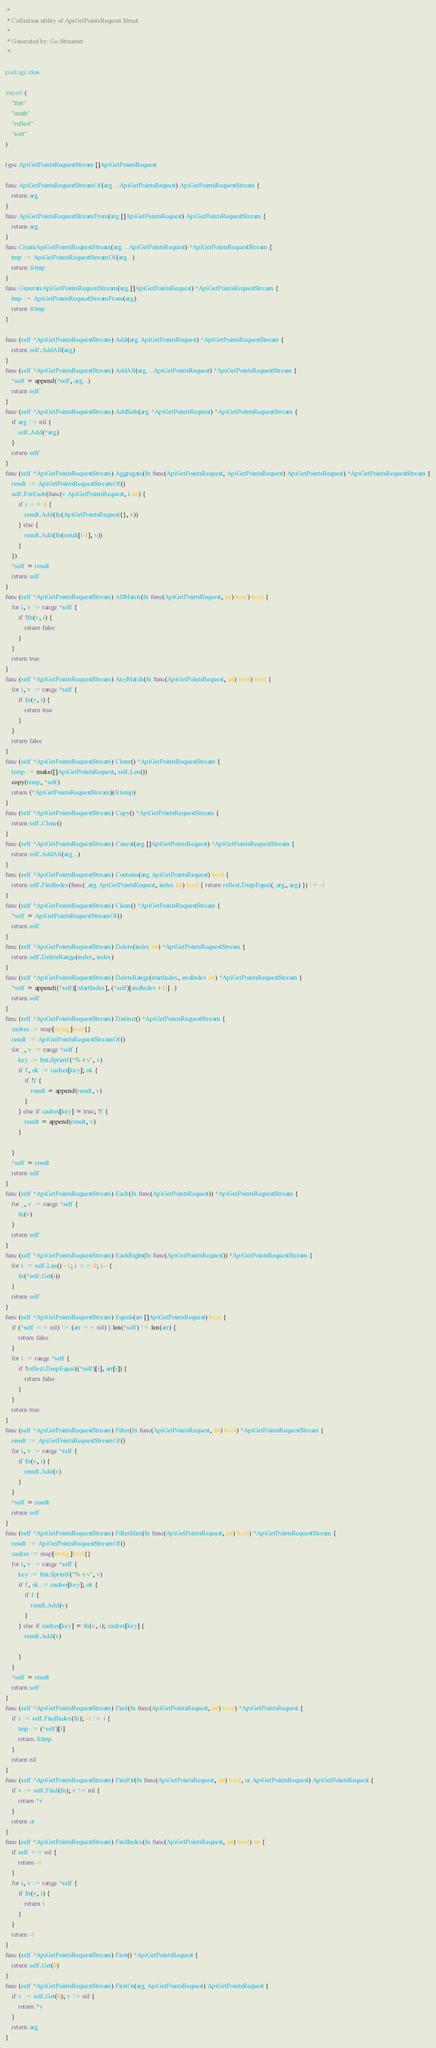<code> <loc_0><loc_0><loc_500><loc_500><_Go_>/*
 * Collection utility of ApiGetPointsRequest Struct
 *
 * Generated by: Go Streamer
 */

package cios

import (
	"fmt"
	"math"
	"reflect"
	"sort"
)

type ApiGetPointsRequestStream []ApiGetPointsRequest

func ApiGetPointsRequestStreamOf(arg ...ApiGetPointsRequest) ApiGetPointsRequestStream {
	return arg
}
func ApiGetPointsRequestStreamFrom(arg []ApiGetPointsRequest) ApiGetPointsRequestStream {
	return arg
}
func CreateApiGetPointsRequestStream(arg ...ApiGetPointsRequest) *ApiGetPointsRequestStream {
	tmp := ApiGetPointsRequestStreamOf(arg...)
	return &tmp
}
func GenerateApiGetPointsRequestStream(arg []ApiGetPointsRequest) *ApiGetPointsRequestStream {
	tmp := ApiGetPointsRequestStreamFrom(arg)
	return &tmp
}

func (self *ApiGetPointsRequestStream) Add(arg ApiGetPointsRequest) *ApiGetPointsRequestStream {
	return self.AddAll(arg)
}
func (self *ApiGetPointsRequestStream) AddAll(arg ...ApiGetPointsRequest) *ApiGetPointsRequestStream {
	*self = append(*self, arg...)
	return self
}
func (self *ApiGetPointsRequestStream) AddSafe(arg *ApiGetPointsRequest) *ApiGetPointsRequestStream {
	if arg != nil {
		self.Add(*arg)
	}
	return self
}
func (self *ApiGetPointsRequestStream) Aggregate(fn func(ApiGetPointsRequest, ApiGetPointsRequest) ApiGetPointsRequest) *ApiGetPointsRequestStream {
	result := ApiGetPointsRequestStreamOf()
	self.ForEach(func(v ApiGetPointsRequest, i int) {
		if i == 0 {
			result.Add(fn(ApiGetPointsRequest{}, v))
		} else {
			result.Add(fn(result[i-1], v))
		}
	})
	*self = result
	return self
}
func (self *ApiGetPointsRequestStream) AllMatch(fn func(ApiGetPointsRequest, int) bool) bool {
	for i, v := range *self {
		if !fn(v, i) {
			return false
		}
	}
	return true
}
func (self *ApiGetPointsRequestStream) AnyMatch(fn func(ApiGetPointsRequest, int) bool) bool {
	for i, v := range *self {
		if fn(v, i) {
			return true
		}
	}
	return false
}
func (self *ApiGetPointsRequestStream) Clone() *ApiGetPointsRequestStream {
	temp := make([]ApiGetPointsRequest, self.Len())
	copy(temp, *self)
	return (*ApiGetPointsRequestStream)(&temp)
}
func (self *ApiGetPointsRequestStream) Copy() *ApiGetPointsRequestStream {
	return self.Clone()
}
func (self *ApiGetPointsRequestStream) Concat(arg []ApiGetPointsRequest) *ApiGetPointsRequestStream {
	return self.AddAll(arg...)
}
func (self *ApiGetPointsRequestStream) Contains(arg ApiGetPointsRequest) bool {
	return self.FindIndex(func(_arg ApiGetPointsRequest, index int) bool { return reflect.DeepEqual(_arg, arg) }) != -1
}
func (self *ApiGetPointsRequestStream) Clean() *ApiGetPointsRequestStream {
	*self = ApiGetPointsRequestStreamOf()
	return self
}
func (self *ApiGetPointsRequestStream) Delete(index int) *ApiGetPointsRequestStream {
	return self.DeleteRange(index, index)
}
func (self *ApiGetPointsRequestStream) DeleteRange(startIndex, endIndex int) *ApiGetPointsRequestStream {
	*self = append((*self)[:startIndex], (*self)[endIndex+1:]...)
	return self
}
func (self *ApiGetPointsRequestStream) Distinct() *ApiGetPointsRequestStream {
	caches := map[string]bool{}
	result := ApiGetPointsRequestStreamOf()
	for _, v := range *self {
		key := fmt.Sprintf("%+v", v)
		if f, ok := caches[key]; ok {
			if !f {
				result = append(result, v)
			}
		} else if caches[key] = true; !f {
			result = append(result, v)
		}

	}
	*self = result
	return self
}
func (self *ApiGetPointsRequestStream) Each(fn func(ApiGetPointsRequest)) *ApiGetPointsRequestStream {
	for _, v := range *self {
		fn(v)
	}
	return self
}
func (self *ApiGetPointsRequestStream) EachRight(fn func(ApiGetPointsRequest)) *ApiGetPointsRequestStream {
	for i := self.Len() - 1; i >= 0; i-- {
		fn(*self.Get(i))
	}
	return self
}
func (self *ApiGetPointsRequestStream) Equals(arr []ApiGetPointsRequest) bool {
	if (*self == nil) != (arr == nil) || len(*self) != len(arr) {
		return false
	}
	for i := range *self {
		if !reflect.DeepEqual((*self)[i], arr[i]) {
			return false
		}
	}
	return true
}
func (self *ApiGetPointsRequestStream) Filter(fn func(ApiGetPointsRequest, int) bool) *ApiGetPointsRequestStream {
	result := ApiGetPointsRequestStreamOf()
	for i, v := range *self {
		if fn(v, i) {
			result.Add(v)
		}
	}
	*self = result
	return self
}
func (self *ApiGetPointsRequestStream) FilterSlim(fn func(ApiGetPointsRequest, int) bool) *ApiGetPointsRequestStream {
	result := ApiGetPointsRequestStreamOf()
	caches := map[string]bool{}
	for i, v := range *self {
		key := fmt.Sprintf("%+v", v)
		if f, ok := caches[key]; ok {
			if f {
				result.Add(v)
			}
		} else if caches[key] = fn(v, i); caches[key] {
			result.Add(v)

		}
	}
	*self = result
	return self
}
func (self *ApiGetPointsRequestStream) Find(fn func(ApiGetPointsRequest, int) bool) *ApiGetPointsRequest {
	if i := self.FindIndex(fn); -1 != i {
		tmp := (*self)[i]
		return &tmp
	}
	return nil
}
func (self *ApiGetPointsRequestStream) FindOr(fn func(ApiGetPointsRequest, int) bool, or ApiGetPointsRequest) ApiGetPointsRequest {
	if v := self.Find(fn); v != nil {
		return *v
	}
	return or
}
func (self *ApiGetPointsRequestStream) FindIndex(fn func(ApiGetPointsRequest, int) bool) int {
	if self == nil {
		return -1
	}
	for i, v := range *self {
		if fn(v, i) {
			return i
		}
	}
	return -1
}
func (self *ApiGetPointsRequestStream) First() *ApiGetPointsRequest {
	return self.Get(0)
}
func (self *ApiGetPointsRequestStream) FirstOr(arg ApiGetPointsRequest) ApiGetPointsRequest {
	if v := self.Get(0); v != nil {
		return *v
	}
	return arg
}</code> 